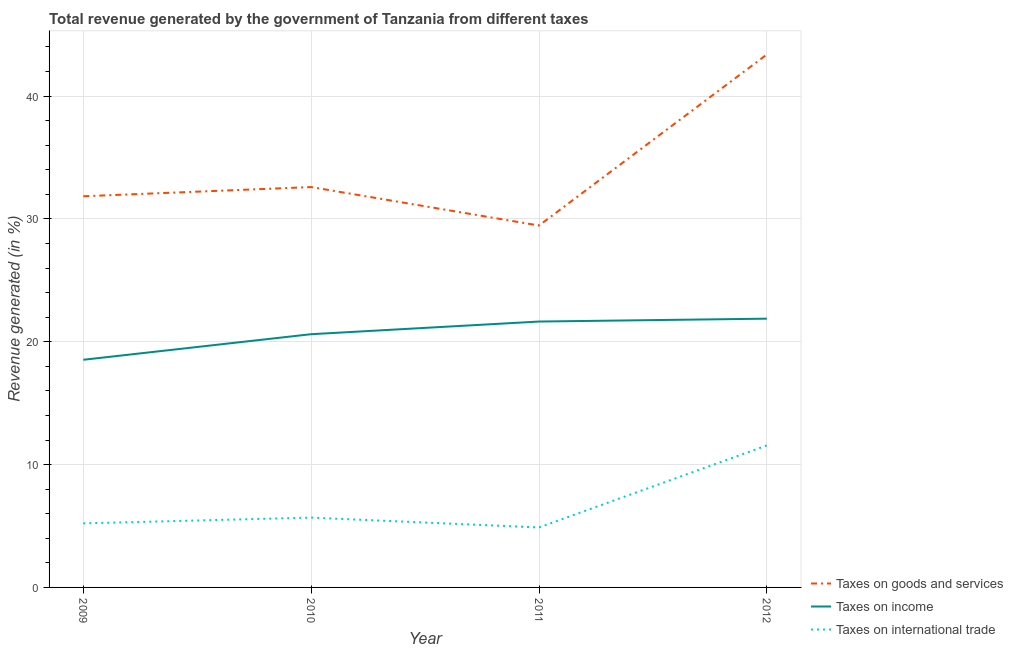How many different coloured lines are there?
Your answer should be very brief. 3. Does the line corresponding to percentage of revenue generated by taxes on income intersect with the line corresponding to percentage of revenue generated by tax on international trade?
Your response must be concise. No. What is the percentage of revenue generated by taxes on goods and services in 2009?
Ensure brevity in your answer.  31.85. Across all years, what is the maximum percentage of revenue generated by taxes on goods and services?
Make the answer very short. 43.39. Across all years, what is the minimum percentage of revenue generated by tax on international trade?
Your response must be concise. 4.88. In which year was the percentage of revenue generated by tax on international trade maximum?
Your answer should be compact. 2012. In which year was the percentage of revenue generated by tax on international trade minimum?
Your answer should be very brief. 2011. What is the total percentage of revenue generated by tax on international trade in the graph?
Offer a very short reply. 27.34. What is the difference between the percentage of revenue generated by tax on international trade in 2010 and that in 2011?
Keep it short and to the point. 0.8. What is the difference between the percentage of revenue generated by taxes on income in 2012 and the percentage of revenue generated by tax on international trade in 2011?
Provide a short and direct response. 17. What is the average percentage of revenue generated by tax on international trade per year?
Provide a succinct answer. 6.84. In the year 2012, what is the difference between the percentage of revenue generated by taxes on goods and services and percentage of revenue generated by tax on international trade?
Offer a very short reply. 31.83. What is the ratio of the percentage of revenue generated by taxes on goods and services in 2010 to that in 2012?
Provide a short and direct response. 0.75. What is the difference between the highest and the second highest percentage of revenue generated by taxes on goods and services?
Offer a very short reply. 10.79. What is the difference between the highest and the lowest percentage of revenue generated by tax on international trade?
Your answer should be compact. 6.68. In how many years, is the percentage of revenue generated by taxes on income greater than the average percentage of revenue generated by taxes on income taken over all years?
Make the answer very short. 2. Is the sum of the percentage of revenue generated by tax on international trade in 2009 and 2012 greater than the maximum percentage of revenue generated by taxes on goods and services across all years?
Offer a very short reply. No. Is it the case that in every year, the sum of the percentage of revenue generated by taxes on goods and services and percentage of revenue generated by taxes on income is greater than the percentage of revenue generated by tax on international trade?
Your response must be concise. Yes. Is the percentage of revenue generated by tax on international trade strictly greater than the percentage of revenue generated by taxes on income over the years?
Offer a terse response. No. Is the percentage of revenue generated by taxes on income strictly less than the percentage of revenue generated by taxes on goods and services over the years?
Provide a short and direct response. Yes. Are the values on the major ticks of Y-axis written in scientific E-notation?
Offer a terse response. No. Where does the legend appear in the graph?
Give a very brief answer. Bottom right. What is the title of the graph?
Provide a succinct answer. Total revenue generated by the government of Tanzania from different taxes. What is the label or title of the Y-axis?
Keep it short and to the point. Revenue generated (in %). What is the Revenue generated (in %) in Taxes on goods and services in 2009?
Your response must be concise. 31.85. What is the Revenue generated (in %) in Taxes on income in 2009?
Give a very brief answer. 18.53. What is the Revenue generated (in %) in Taxes on international trade in 2009?
Provide a short and direct response. 5.22. What is the Revenue generated (in %) of Taxes on goods and services in 2010?
Provide a succinct answer. 32.6. What is the Revenue generated (in %) of Taxes on income in 2010?
Your response must be concise. 20.62. What is the Revenue generated (in %) in Taxes on international trade in 2010?
Provide a succinct answer. 5.68. What is the Revenue generated (in %) in Taxes on goods and services in 2011?
Your response must be concise. 29.47. What is the Revenue generated (in %) in Taxes on income in 2011?
Keep it short and to the point. 21.65. What is the Revenue generated (in %) of Taxes on international trade in 2011?
Offer a very short reply. 4.88. What is the Revenue generated (in %) of Taxes on goods and services in 2012?
Your response must be concise. 43.39. What is the Revenue generated (in %) of Taxes on income in 2012?
Offer a very short reply. 21.88. What is the Revenue generated (in %) of Taxes on international trade in 2012?
Ensure brevity in your answer.  11.56. Across all years, what is the maximum Revenue generated (in %) of Taxes on goods and services?
Provide a succinct answer. 43.39. Across all years, what is the maximum Revenue generated (in %) of Taxes on income?
Your answer should be compact. 21.88. Across all years, what is the maximum Revenue generated (in %) of Taxes on international trade?
Offer a very short reply. 11.56. Across all years, what is the minimum Revenue generated (in %) of Taxes on goods and services?
Provide a short and direct response. 29.47. Across all years, what is the minimum Revenue generated (in %) of Taxes on income?
Provide a succinct answer. 18.53. Across all years, what is the minimum Revenue generated (in %) in Taxes on international trade?
Ensure brevity in your answer.  4.88. What is the total Revenue generated (in %) in Taxes on goods and services in the graph?
Ensure brevity in your answer.  137.3. What is the total Revenue generated (in %) of Taxes on income in the graph?
Give a very brief answer. 82.68. What is the total Revenue generated (in %) of Taxes on international trade in the graph?
Offer a terse response. 27.34. What is the difference between the Revenue generated (in %) in Taxes on goods and services in 2009 and that in 2010?
Provide a short and direct response. -0.75. What is the difference between the Revenue generated (in %) in Taxes on income in 2009 and that in 2010?
Your response must be concise. -2.08. What is the difference between the Revenue generated (in %) in Taxes on international trade in 2009 and that in 2010?
Provide a succinct answer. -0.47. What is the difference between the Revenue generated (in %) in Taxes on goods and services in 2009 and that in 2011?
Ensure brevity in your answer.  2.38. What is the difference between the Revenue generated (in %) of Taxes on income in 2009 and that in 2011?
Your answer should be compact. -3.11. What is the difference between the Revenue generated (in %) in Taxes on international trade in 2009 and that in 2011?
Offer a very short reply. 0.33. What is the difference between the Revenue generated (in %) of Taxes on goods and services in 2009 and that in 2012?
Provide a short and direct response. -11.54. What is the difference between the Revenue generated (in %) of Taxes on income in 2009 and that in 2012?
Make the answer very short. -3.35. What is the difference between the Revenue generated (in %) of Taxes on international trade in 2009 and that in 2012?
Offer a very short reply. -6.35. What is the difference between the Revenue generated (in %) in Taxes on goods and services in 2010 and that in 2011?
Offer a very short reply. 3.13. What is the difference between the Revenue generated (in %) in Taxes on income in 2010 and that in 2011?
Your answer should be very brief. -1.03. What is the difference between the Revenue generated (in %) in Taxes on international trade in 2010 and that in 2011?
Your response must be concise. 0.8. What is the difference between the Revenue generated (in %) of Taxes on goods and services in 2010 and that in 2012?
Give a very brief answer. -10.79. What is the difference between the Revenue generated (in %) in Taxes on income in 2010 and that in 2012?
Ensure brevity in your answer.  -1.26. What is the difference between the Revenue generated (in %) in Taxes on international trade in 2010 and that in 2012?
Your answer should be very brief. -5.88. What is the difference between the Revenue generated (in %) of Taxes on goods and services in 2011 and that in 2012?
Your response must be concise. -13.93. What is the difference between the Revenue generated (in %) of Taxes on income in 2011 and that in 2012?
Your response must be concise. -0.23. What is the difference between the Revenue generated (in %) of Taxes on international trade in 2011 and that in 2012?
Ensure brevity in your answer.  -6.68. What is the difference between the Revenue generated (in %) in Taxes on goods and services in 2009 and the Revenue generated (in %) in Taxes on income in 2010?
Ensure brevity in your answer.  11.23. What is the difference between the Revenue generated (in %) in Taxes on goods and services in 2009 and the Revenue generated (in %) in Taxes on international trade in 2010?
Make the answer very short. 26.16. What is the difference between the Revenue generated (in %) in Taxes on income in 2009 and the Revenue generated (in %) in Taxes on international trade in 2010?
Offer a terse response. 12.85. What is the difference between the Revenue generated (in %) in Taxes on goods and services in 2009 and the Revenue generated (in %) in Taxes on income in 2011?
Your answer should be compact. 10.2. What is the difference between the Revenue generated (in %) of Taxes on goods and services in 2009 and the Revenue generated (in %) of Taxes on international trade in 2011?
Provide a succinct answer. 26.97. What is the difference between the Revenue generated (in %) in Taxes on income in 2009 and the Revenue generated (in %) in Taxes on international trade in 2011?
Provide a short and direct response. 13.65. What is the difference between the Revenue generated (in %) in Taxes on goods and services in 2009 and the Revenue generated (in %) in Taxes on income in 2012?
Provide a short and direct response. 9.97. What is the difference between the Revenue generated (in %) in Taxes on goods and services in 2009 and the Revenue generated (in %) in Taxes on international trade in 2012?
Provide a succinct answer. 20.29. What is the difference between the Revenue generated (in %) of Taxes on income in 2009 and the Revenue generated (in %) of Taxes on international trade in 2012?
Your answer should be compact. 6.97. What is the difference between the Revenue generated (in %) of Taxes on goods and services in 2010 and the Revenue generated (in %) of Taxes on income in 2011?
Offer a very short reply. 10.95. What is the difference between the Revenue generated (in %) of Taxes on goods and services in 2010 and the Revenue generated (in %) of Taxes on international trade in 2011?
Your answer should be compact. 27.71. What is the difference between the Revenue generated (in %) in Taxes on income in 2010 and the Revenue generated (in %) in Taxes on international trade in 2011?
Ensure brevity in your answer.  15.73. What is the difference between the Revenue generated (in %) of Taxes on goods and services in 2010 and the Revenue generated (in %) of Taxes on income in 2012?
Give a very brief answer. 10.72. What is the difference between the Revenue generated (in %) of Taxes on goods and services in 2010 and the Revenue generated (in %) of Taxes on international trade in 2012?
Offer a very short reply. 21.04. What is the difference between the Revenue generated (in %) of Taxes on income in 2010 and the Revenue generated (in %) of Taxes on international trade in 2012?
Your answer should be very brief. 9.06. What is the difference between the Revenue generated (in %) of Taxes on goods and services in 2011 and the Revenue generated (in %) of Taxes on income in 2012?
Your answer should be very brief. 7.58. What is the difference between the Revenue generated (in %) of Taxes on goods and services in 2011 and the Revenue generated (in %) of Taxes on international trade in 2012?
Ensure brevity in your answer.  17.9. What is the difference between the Revenue generated (in %) of Taxes on income in 2011 and the Revenue generated (in %) of Taxes on international trade in 2012?
Give a very brief answer. 10.09. What is the average Revenue generated (in %) in Taxes on goods and services per year?
Make the answer very short. 34.32. What is the average Revenue generated (in %) in Taxes on income per year?
Offer a terse response. 20.67. What is the average Revenue generated (in %) of Taxes on international trade per year?
Your answer should be compact. 6.84. In the year 2009, what is the difference between the Revenue generated (in %) of Taxes on goods and services and Revenue generated (in %) of Taxes on income?
Provide a short and direct response. 13.31. In the year 2009, what is the difference between the Revenue generated (in %) of Taxes on goods and services and Revenue generated (in %) of Taxes on international trade?
Your answer should be compact. 26.63. In the year 2009, what is the difference between the Revenue generated (in %) in Taxes on income and Revenue generated (in %) in Taxes on international trade?
Offer a very short reply. 13.32. In the year 2010, what is the difference between the Revenue generated (in %) of Taxes on goods and services and Revenue generated (in %) of Taxes on income?
Provide a short and direct response. 11.98. In the year 2010, what is the difference between the Revenue generated (in %) in Taxes on goods and services and Revenue generated (in %) in Taxes on international trade?
Offer a terse response. 26.91. In the year 2010, what is the difference between the Revenue generated (in %) in Taxes on income and Revenue generated (in %) in Taxes on international trade?
Provide a succinct answer. 14.93. In the year 2011, what is the difference between the Revenue generated (in %) in Taxes on goods and services and Revenue generated (in %) in Taxes on income?
Your answer should be compact. 7.82. In the year 2011, what is the difference between the Revenue generated (in %) in Taxes on goods and services and Revenue generated (in %) in Taxes on international trade?
Your answer should be compact. 24.58. In the year 2011, what is the difference between the Revenue generated (in %) in Taxes on income and Revenue generated (in %) in Taxes on international trade?
Your answer should be very brief. 16.76. In the year 2012, what is the difference between the Revenue generated (in %) in Taxes on goods and services and Revenue generated (in %) in Taxes on income?
Your answer should be very brief. 21.51. In the year 2012, what is the difference between the Revenue generated (in %) of Taxes on goods and services and Revenue generated (in %) of Taxes on international trade?
Your answer should be very brief. 31.83. In the year 2012, what is the difference between the Revenue generated (in %) of Taxes on income and Revenue generated (in %) of Taxes on international trade?
Ensure brevity in your answer.  10.32. What is the ratio of the Revenue generated (in %) in Taxes on goods and services in 2009 to that in 2010?
Your response must be concise. 0.98. What is the ratio of the Revenue generated (in %) in Taxes on income in 2009 to that in 2010?
Your answer should be compact. 0.9. What is the ratio of the Revenue generated (in %) of Taxes on international trade in 2009 to that in 2010?
Provide a succinct answer. 0.92. What is the ratio of the Revenue generated (in %) in Taxes on goods and services in 2009 to that in 2011?
Offer a very short reply. 1.08. What is the ratio of the Revenue generated (in %) in Taxes on income in 2009 to that in 2011?
Ensure brevity in your answer.  0.86. What is the ratio of the Revenue generated (in %) in Taxes on international trade in 2009 to that in 2011?
Your response must be concise. 1.07. What is the ratio of the Revenue generated (in %) in Taxes on goods and services in 2009 to that in 2012?
Offer a very short reply. 0.73. What is the ratio of the Revenue generated (in %) in Taxes on income in 2009 to that in 2012?
Your answer should be compact. 0.85. What is the ratio of the Revenue generated (in %) of Taxes on international trade in 2009 to that in 2012?
Ensure brevity in your answer.  0.45. What is the ratio of the Revenue generated (in %) in Taxes on goods and services in 2010 to that in 2011?
Your response must be concise. 1.11. What is the ratio of the Revenue generated (in %) of Taxes on international trade in 2010 to that in 2011?
Provide a short and direct response. 1.16. What is the ratio of the Revenue generated (in %) of Taxes on goods and services in 2010 to that in 2012?
Your answer should be very brief. 0.75. What is the ratio of the Revenue generated (in %) of Taxes on income in 2010 to that in 2012?
Offer a very short reply. 0.94. What is the ratio of the Revenue generated (in %) of Taxes on international trade in 2010 to that in 2012?
Provide a short and direct response. 0.49. What is the ratio of the Revenue generated (in %) of Taxes on goods and services in 2011 to that in 2012?
Offer a terse response. 0.68. What is the ratio of the Revenue generated (in %) in Taxes on income in 2011 to that in 2012?
Make the answer very short. 0.99. What is the ratio of the Revenue generated (in %) of Taxes on international trade in 2011 to that in 2012?
Ensure brevity in your answer.  0.42. What is the difference between the highest and the second highest Revenue generated (in %) of Taxes on goods and services?
Keep it short and to the point. 10.79. What is the difference between the highest and the second highest Revenue generated (in %) in Taxes on income?
Offer a terse response. 0.23. What is the difference between the highest and the second highest Revenue generated (in %) of Taxes on international trade?
Make the answer very short. 5.88. What is the difference between the highest and the lowest Revenue generated (in %) in Taxes on goods and services?
Offer a terse response. 13.93. What is the difference between the highest and the lowest Revenue generated (in %) in Taxes on income?
Offer a terse response. 3.35. What is the difference between the highest and the lowest Revenue generated (in %) of Taxes on international trade?
Give a very brief answer. 6.68. 